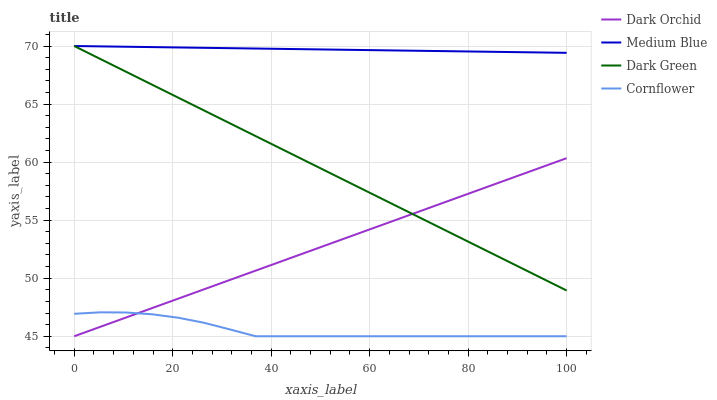Does Cornflower have the minimum area under the curve?
Answer yes or no. Yes. Does Medium Blue have the maximum area under the curve?
Answer yes or no. Yes. Does Dark Orchid have the minimum area under the curve?
Answer yes or no. No. Does Dark Orchid have the maximum area under the curve?
Answer yes or no. No. Is Medium Blue the smoothest?
Answer yes or no. Yes. Is Cornflower the roughest?
Answer yes or no. Yes. Is Dark Orchid the smoothest?
Answer yes or no. No. Is Dark Orchid the roughest?
Answer yes or no. No. Does Cornflower have the lowest value?
Answer yes or no. Yes. Does Medium Blue have the lowest value?
Answer yes or no. No. Does Dark Green have the highest value?
Answer yes or no. Yes. Does Dark Orchid have the highest value?
Answer yes or no. No. Is Dark Orchid less than Medium Blue?
Answer yes or no. Yes. Is Medium Blue greater than Cornflower?
Answer yes or no. Yes. Does Dark Orchid intersect Cornflower?
Answer yes or no. Yes. Is Dark Orchid less than Cornflower?
Answer yes or no. No. Is Dark Orchid greater than Cornflower?
Answer yes or no. No. Does Dark Orchid intersect Medium Blue?
Answer yes or no. No. 